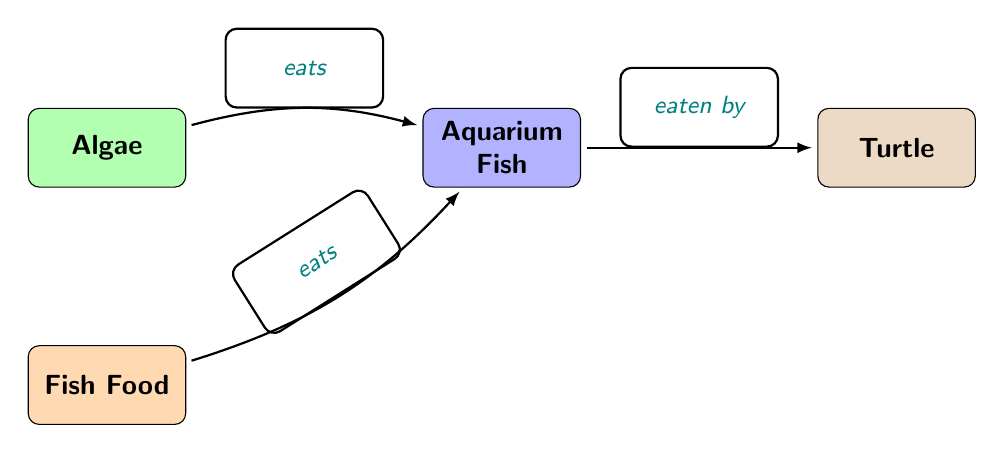What is the first level in the food chain? The first level in the diagram represents the base of the food chain, which is where producers like algae typically occupy. This is indicated as the node at the top of the diagram.
Answer: Algae Which organism is eaten by the turtle? The diagram shows a directed edge from the aquarium fish to the turtle, indicating that the fish are the food source for the turtle in the food chain.
Answer: Aquarium Fish How many nodes are there in the diagram? The diagram contains four distinct nodes: algae, aquarium fish, fish food, and a turtle, representing different components of the food chain.
Answer: 4 What do aquarium fish eat? According to the diagram, aquarium fish are connected to fish food through an "eats" relationship, which specifies that fish food is a food source for aquarium fish.
Answer: Fish Food What level in the food chain does fish food represent? In this food chain, fish food acts as a secondary source of energy, which supports the primary consumers (aquarium fish). It is not at the base level like algae but rather one step higher up.
Answer: Second level What two items do aquarium fish consume? The diagram indicates that aquarium fish eat both algae and fish food, depicted by incoming arrows labeled with the 'eats' relationship from both sources to the fish.
Answer: Algae and Fish Food Which organism is a primary consumer? The aquarium fish are classified as primary consumers in the food chain because they feed directly on producers (algae) and secondary sources (fish food).
Answer: Aquarium Fish What is the relationship between algae and aquarium fish? The diagram specifies that algae provide a food source for aquarium fish, indicated by the connection with the label "eats." This illustrates the flow of energy from the producer to the primary consumer.
Answer: Eats How many direct edges are leaving from the aquarium fish? There is one direct edge leaving from the aquarium fish, pointing towards the turtle, which indicates that the turtle consumes the aquarium fish.
Answer: 1 